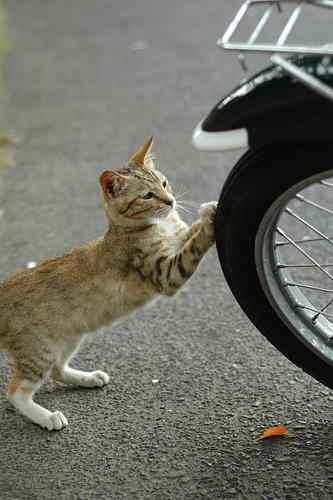What could potentially puncture the tire? Please explain your reasoning. claws. The cat's sharp claws could make a hole in the tire. 